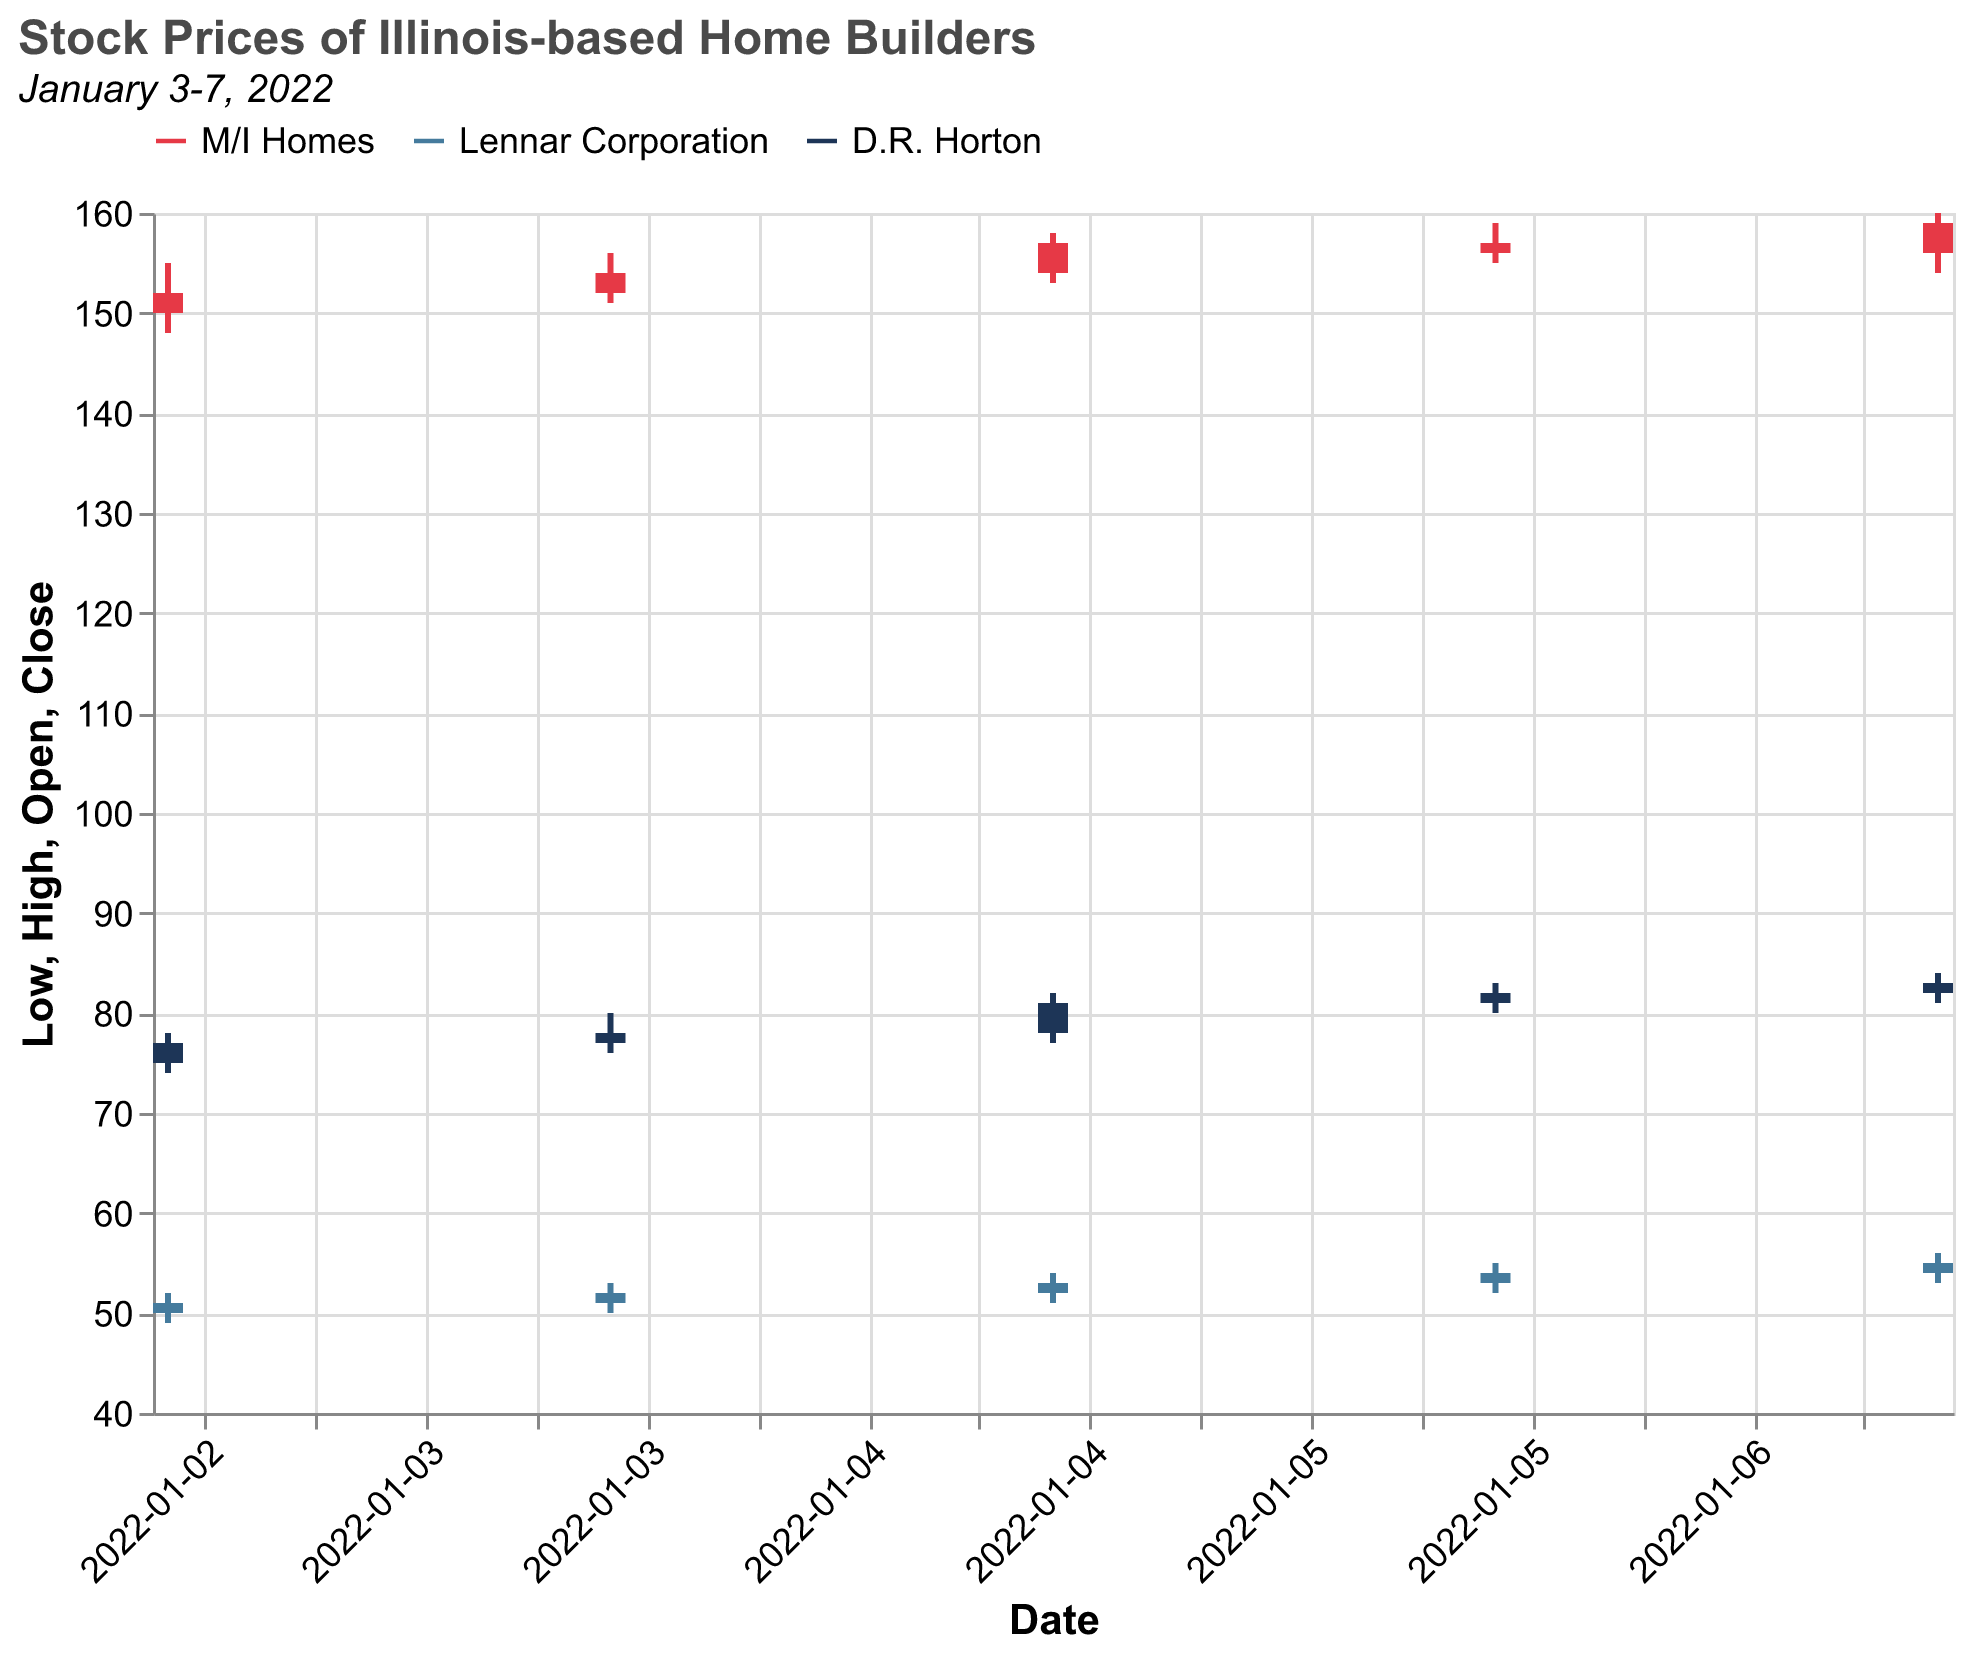What's the closing price of M/I Homes on January 5, 2022? Look at the candlestick where the date is January 5, 2022, and find the “Close” value for M/I Homes, which is 157.
Answer: 157 What company had the highest closing price on January 7, 2022? Compare the closing prices of M/I Homes (159), Lennar Corporation (55), and D.R. Horton (83) on January 7, 2022. The highest is M/I Homes at 159.
Answer: M/I Homes How did the closing price of Lennar Corporation change from January 3 to January 7, 2022? Check Lennar Corporation's closing price on January 3 (51) and January 7 (55). The change is: 55 - 51 = 4.
Answer: Increased by 4 What is the average high price of D.R. Horton for the period January 3-7, 2022? Get the high prices of D.R. Horton for these dates: 78, 80, 82, 83, 84. Sum these (78+80+82+83+84 = 407) and divide by the number of data points (5), resulting in 407/5 = 81.4.
Answer: 81.4 Which company showed the most significant increase in closing prices over the week? Calculate the change in closing prices for each company: M/I Homes (159-152=7), Lennar Corporation (55-51=4), D.R. Horton (83-77=6). The most significant increase is for M/I Homes (7).
Answer: M/I Homes What was the highest single-day volume for any company? Check the volumes for all companies. The highest volume is for M/I Homes on January 7 with 120,000.
Answer: 120,000 What's the difference between the highest and lowest prices for Lennar Corporation on January 6, 2022? Identify the highest (55) and lowest (52) prices for Lennar Corporation on January 6. Calculate the difference: 55 - 52 = 3.
Answer: 3 What was the trend of the closing prices for D.R. Horton over the week? Review the closing prices for D.R. Horton: 77, 78, 81, 82, 83. The trend is consistently increasing throughout the week.
Answer: Increasing Between January 4-5, which company had the largest relative increase in opening price? Calculate the relative increase for January 4 (Open) to January 5 (Open) for each company: M/I Homes ((154-152)/152 = 1.32%), Lennar Corporation ((52-51)/51 = 1.96%), and D.R. Horton ((78-77)/77 = 1.30%). Lennar Corporation had the largest relative increase at 1.96%.
Answer: Lennar Corporation 